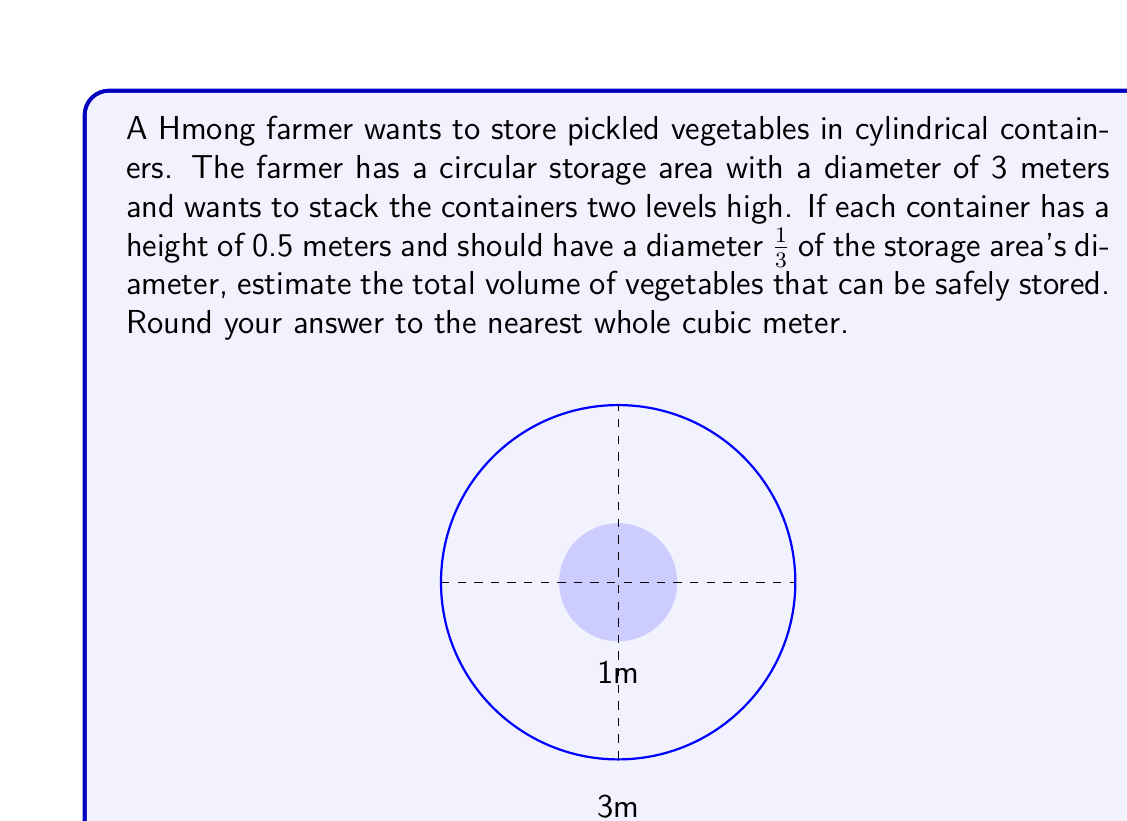Solve this math problem. Let's approach this step-by-step:

1) First, let's calculate the diameter of each container:
   Container diameter = $\frac{1}{3} \times 3\text{ m} = 1\text{ m}$

2) Now, let's calculate the radius of each container:
   Container radius = $\frac{1\text{ m}}{2} = 0.5\text{ m}$

3) The volume of a cylinder is given by the formula:
   $V = \pi r^2 h$
   where $r$ is the radius and $h$ is the height.

4) Substituting our values:
   $V = \pi \times (0.5\text{ m})^2 \times 0.5\text{ m}$
   $V = \pi \times 0.25\text{ m}^2 \times 0.5\text{ m}$
   $V = 0.125\pi\text{ m}^3$

5) Now, let's calculate how many containers can fit in the circular storage area:
   Area of storage = $\pi R^2 = \pi \times (1.5\text{ m})^2 = 2.25\pi\text{ m}^2$
   Area of one container = $\pi r^2 = \pi \times (0.5\text{ m})^2 = 0.25\pi\text{ m}^2$
   Number of containers per level = $\frac{2.25\pi\text{ m}^2}{0.25\pi\text{ m}^2} = 9$

6) Since we're stacking two levels high, the total number of containers is:
   Total containers = $9 \times 2 = 18$

7) Therefore, the total volume is:
   Total volume = $18 \times 0.125\pi\text{ m}^3 = 2.25\pi\text{ m}^3 \approx 7.07\text{ m}^3$

8) Rounding to the nearest whole cubic meter:
   Total volume ≈ $7\text{ m}^3$
Answer: $7\text{ m}^3$ 